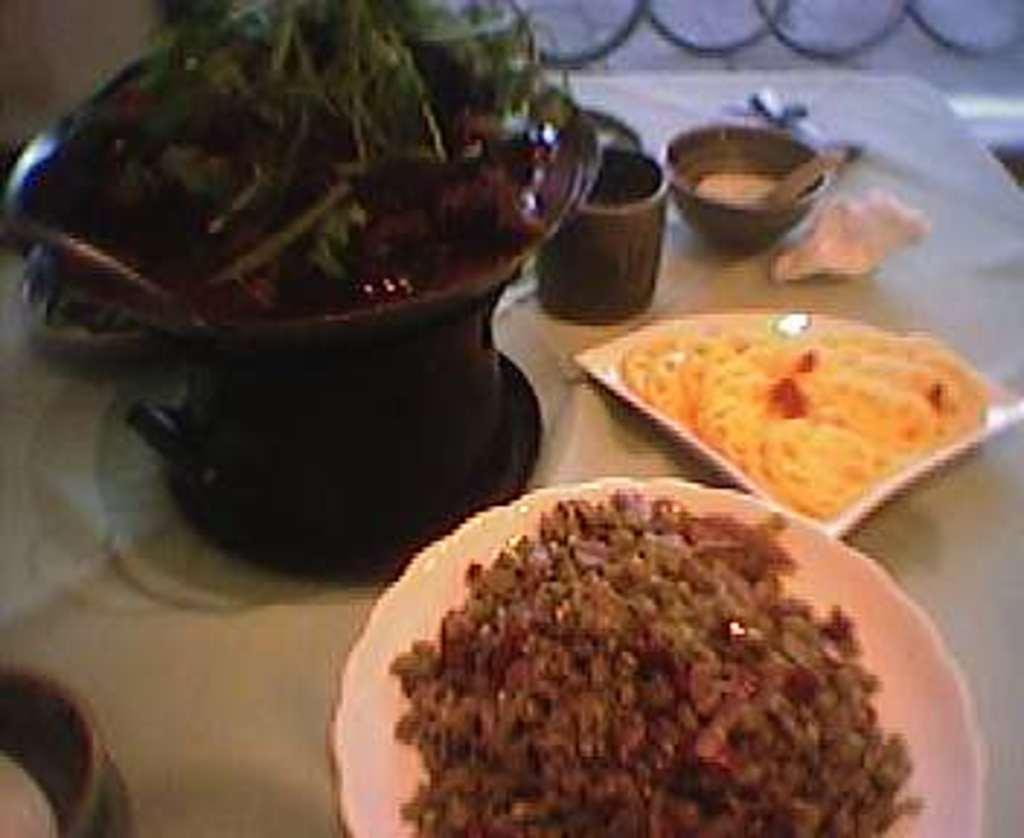What is on the plate that is visible in the image? There is food on the plate in the image. What else can be seen on the table besides the plate? There is a bowl and tissue paper visible in the image. What type of vegetation is present in the image? Leaves are visible in the image. How would you describe the clarity of the image? The image is slightly blurred. What is the opinion of the alarm in the image? There is no alarm present in the image, so it is not possible to determine its opinion. What day of the week is depicted in the image? The image does not show any specific day of the week; it only contains a plate, food, a bowl, tissue paper, leaves, and is slightly blurred. 